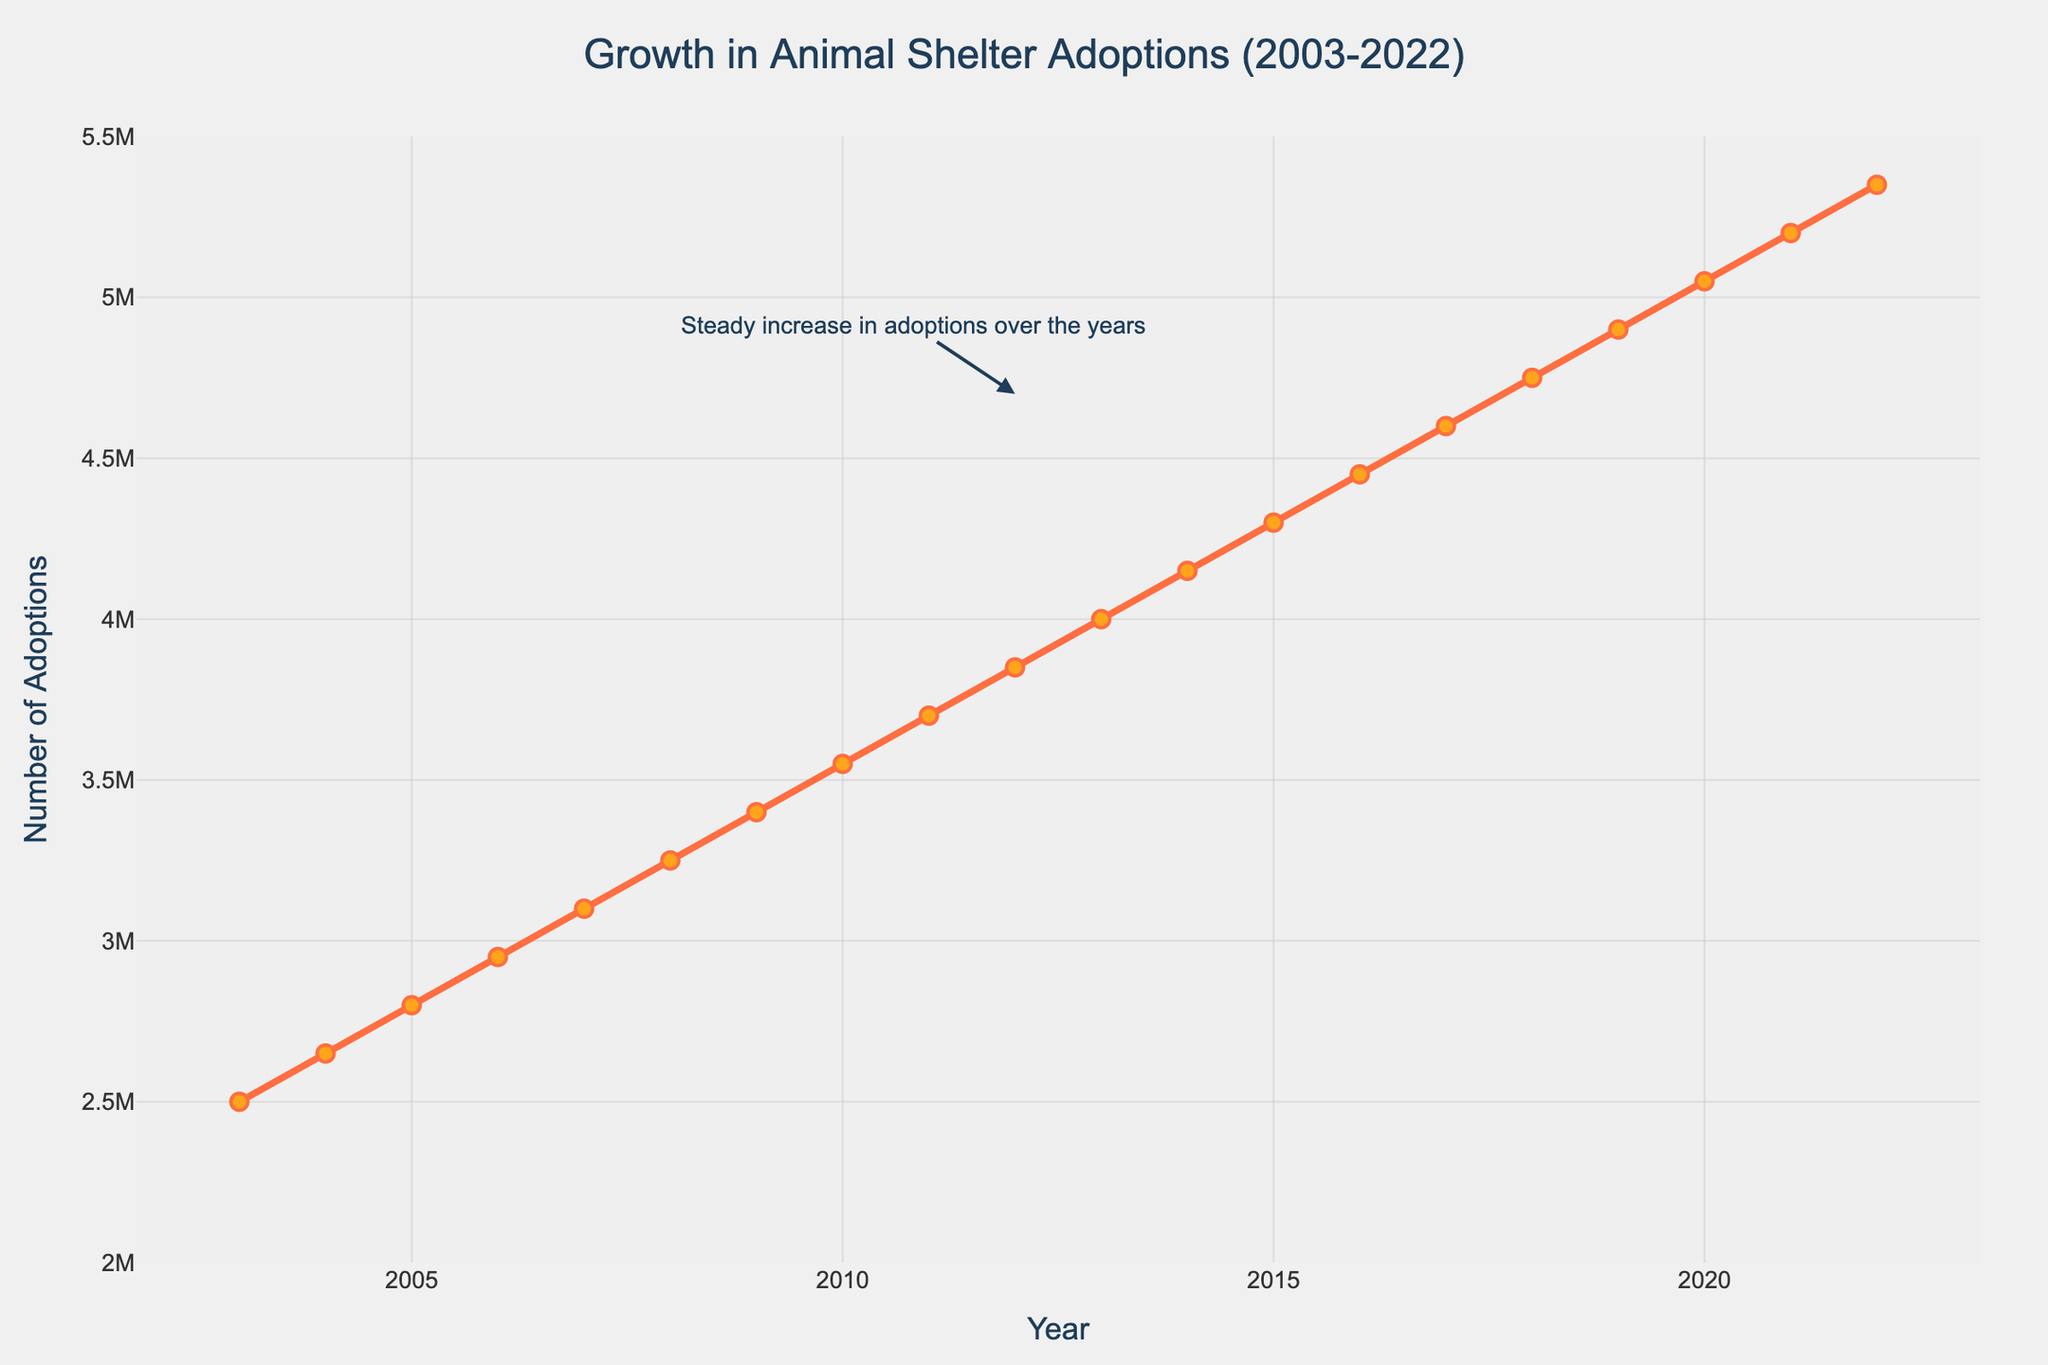What is the trend in animal shelter adoptions from 2003 to 2022? The figure shows a steady increase in the number of adoptions from 2003 to 2022. The adoption numbers rise consistently every year.
Answer: Steady increase What was the number of animal shelter adoptions in 2010? Locate the year 2010 on the x-axis and refer to the corresponding point on the y-axis. The y-axis value indicates the number of adoptions.
Answer: 3,550,000 How many more adoptions were there in 2022 compared to 2003? Subtract the adoptions in 2003 from those in 2022: 5,350,000 (2022) - 2,500,000 (2003).
Answer: 2,850,000 Which year experienced the highest number of adoptions? The end point of the line graph represents the year with the highest number of adoptions, which is 2022.
Answer: 2022 Compare the annual growth in adoptions between 2003 and 2004 to that between 2021 and 2022. Calculate the difference in adoptions for each period: (2004 - 2003) = 150,000; (2022 - 2021) = 150,000.
Answer: Same growth How much did the number of adoptions increase on average each year from 2003 to 2022? Calculate the total increase over all years: 5,350,000 (2022) - 2,500,000 (2003) = 2,850,000. Average increase per year = 2,850,000 / 19 years.
Answer: 150,000 Is there any year in which the number of adoptions decreased? Analyze the continuous nature of the upward trend in the line chart. The number of adoptions increases every year with no dips.
Answer: No What visualization feature highlights the continuous growth of adoptions? The line chart shows a consistent upward slope without any sharp declines, and there is an annotation indicating steady growth.
Answer: Upward slope and annotation What is the prominent color of the line used to represent adoptions in the chart? The line representing adoptions is prominently colored red.
Answer: Red 